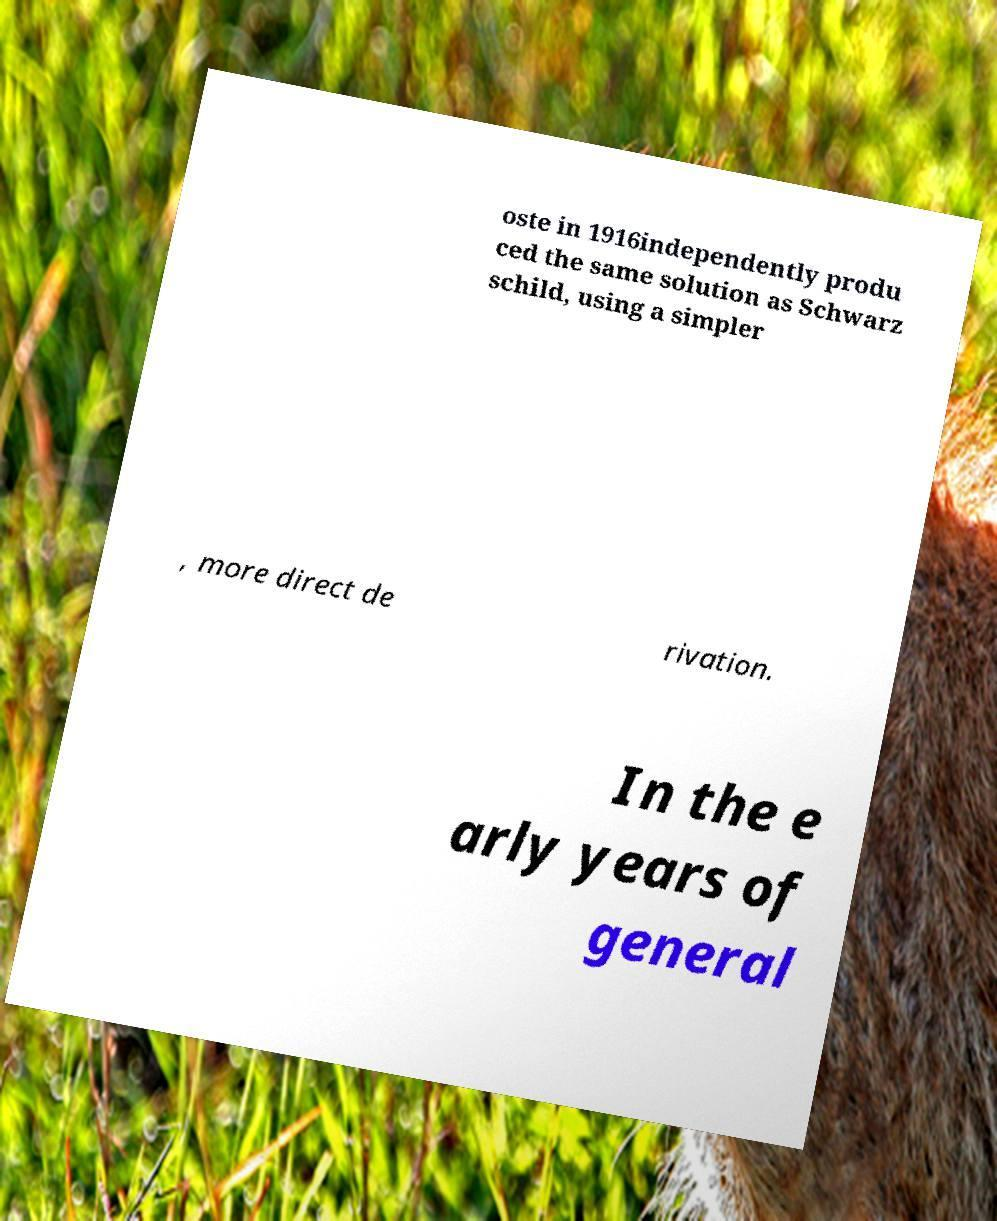Can you read and provide the text displayed in the image?This photo seems to have some interesting text. Can you extract and type it out for me? oste in 1916independently produ ced the same solution as Schwarz schild, using a simpler , more direct de rivation. In the e arly years of general 